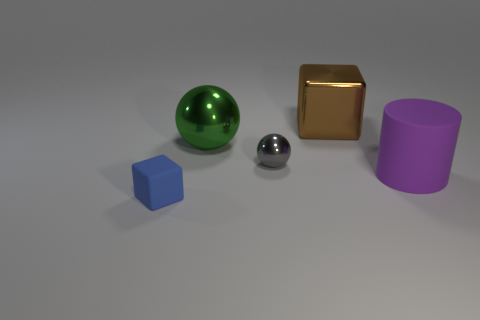What number of brown things are there? In the image, there are no brown objects present. We can see a collection of geometric shapes including a green sphere, a gold-colored cube, a silver sphere, a blue cube, and a purple cylinder, but nothing that is brown. 